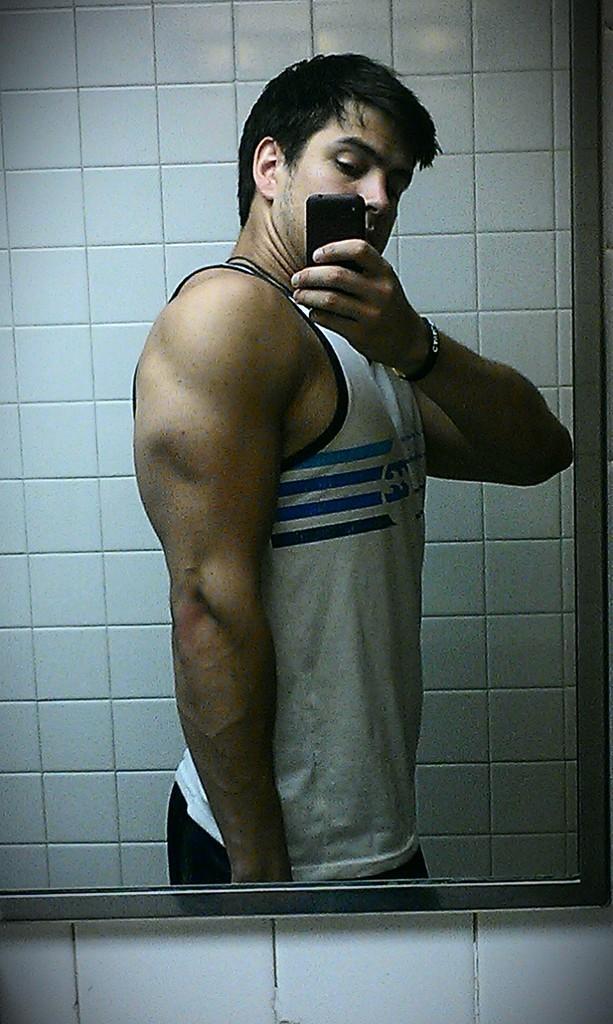Can you describe this image briefly? In this image, we can see a person reflection in the mirror. This person is wearing clothes and holding a phone with his hand. 